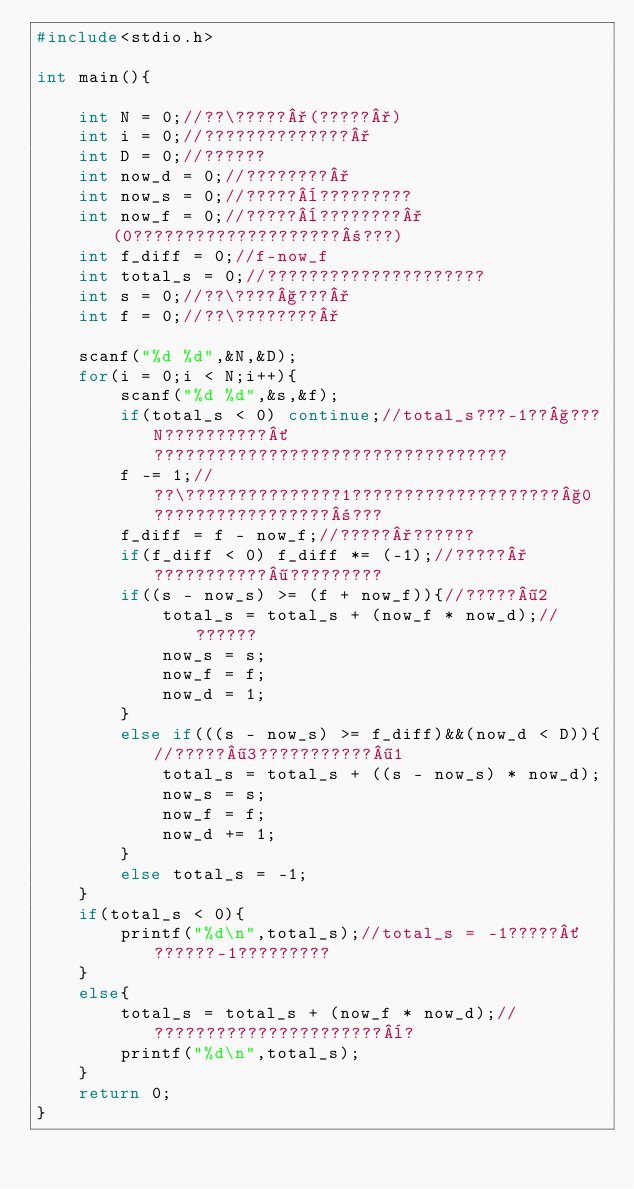<code> <loc_0><loc_0><loc_500><loc_500><_C_>#include<stdio.h>

int main(){
    
	int N = 0;//??\?????°(?????°)
	int i = 0;//??????????????°
	int D = 0;//??????
	int now_d = 0;//????????°
	int now_s = 0;//?????¨?????????
    int now_f = 0;//?????¨????????°(0????????????????????±???)
	int f_diff = 0;//f-now_f    
	int total_s = 0;//?????????????????????
	int s = 0;//??\????§???°
	int f = 0;//??\????????°
	
	scanf("%d %d",&N,&D);
	for(i = 0;i < N;i++){
		scanf("%d %d",&s,&f);
	    if(total_s < 0) continue;//total_s???-1??§???N??????????´??????????????????????????????????
		f -= 1;//??\???????????????1????????????????????§0?????????????????±???
		f_diff = f - now_f;//?????°??????
	    if(f_diff < 0) f_diff *= (-1);//?????°???????????¶?????????
		if((s - now_s) >= (f + now_f)){//?????¶2
			total_s = total_s + (now_f * now_d);//??????
			now_s = s;
			now_f = f;
			now_d = 1;
		}
        else if(((s - now_s) >= f_diff)&&(now_d < D)){//?????¶3???????????¶1
			total_s = total_s + ((s - now_s) * now_d);
			now_s = s;
			now_f = f;
			now_d += 1;
		}
        else total_s = -1;
	}
	if(total_s < 0){ 
		printf("%d\n",total_s);//total_s = -1?????´??????-1?????????
	}
    else{
		total_s = total_s + (now_f * now_d);//??????????????????????¨?
		printf("%d\n",total_s);
	}
    return 0;
}</code> 